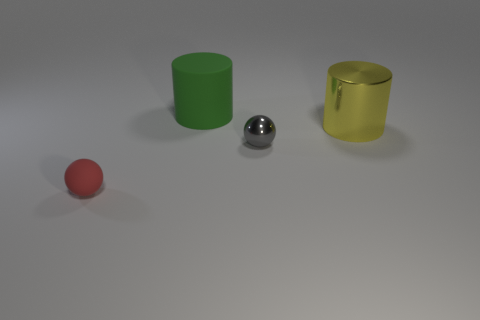How many cylinders are there?
Make the answer very short. 2. Do the small thing behind the tiny rubber object and the large cylinder that is behind the large metal object have the same material?
Make the answer very short. No. What is the green cylinder made of?
Your response must be concise. Rubber. How many things have the same material as the green cylinder?
Give a very brief answer. 1. How many matte objects are either tiny red objects or large cylinders?
Ensure brevity in your answer.  2. There is a small thing that is on the right side of the green object; is it the same shape as the small object on the left side of the green thing?
Give a very brief answer. Yes. There is a thing that is both on the left side of the gray sphere and in front of the big yellow cylinder; what is its color?
Provide a short and direct response. Red. There is a ball right of the big green rubber thing; does it have the same size as the cylinder in front of the big green matte cylinder?
Make the answer very short. No. What number of small metallic objects have the same color as the large metallic cylinder?
Provide a succinct answer. 0. How many large things are either purple shiny balls or matte spheres?
Give a very brief answer. 0. 